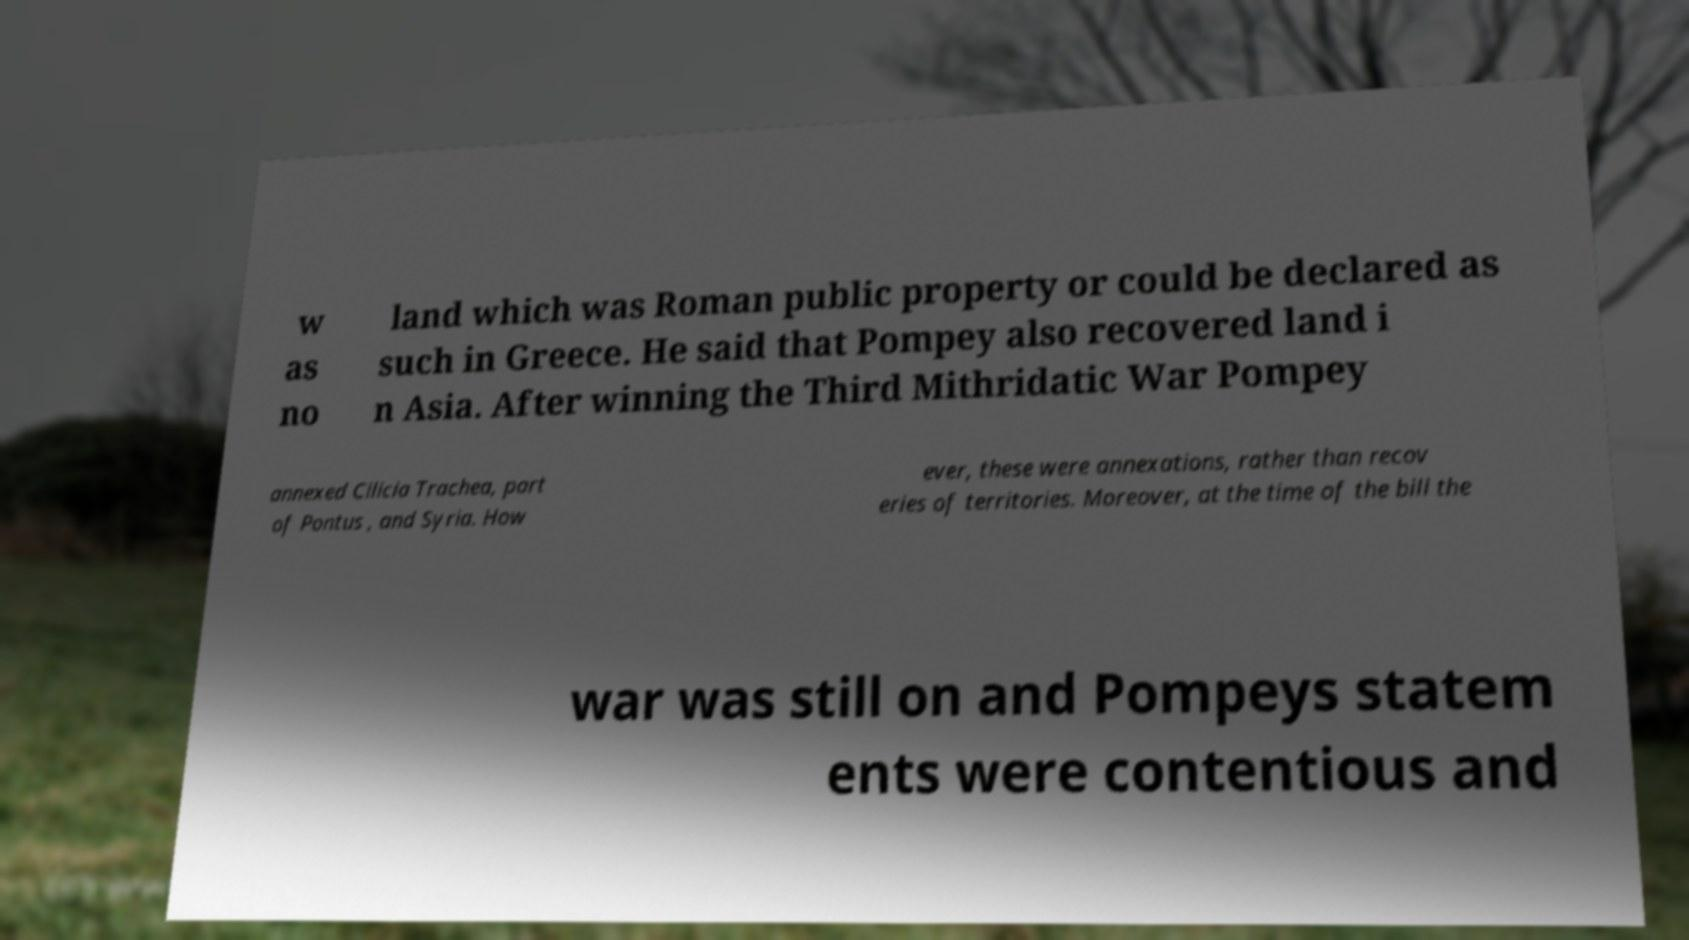Please read and relay the text visible in this image. What does it say? w as no land which was Roman public property or could be declared as such in Greece. He said that Pompey also recovered land i n Asia. After winning the Third Mithridatic War Pompey annexed Cilicia Trachea, part of Pontus , and Syria. How ever, these were annexations, rather than recov eries of territories. Moreover, at the time of the bill the war was still on and Pompeys statem ents were contentious and 